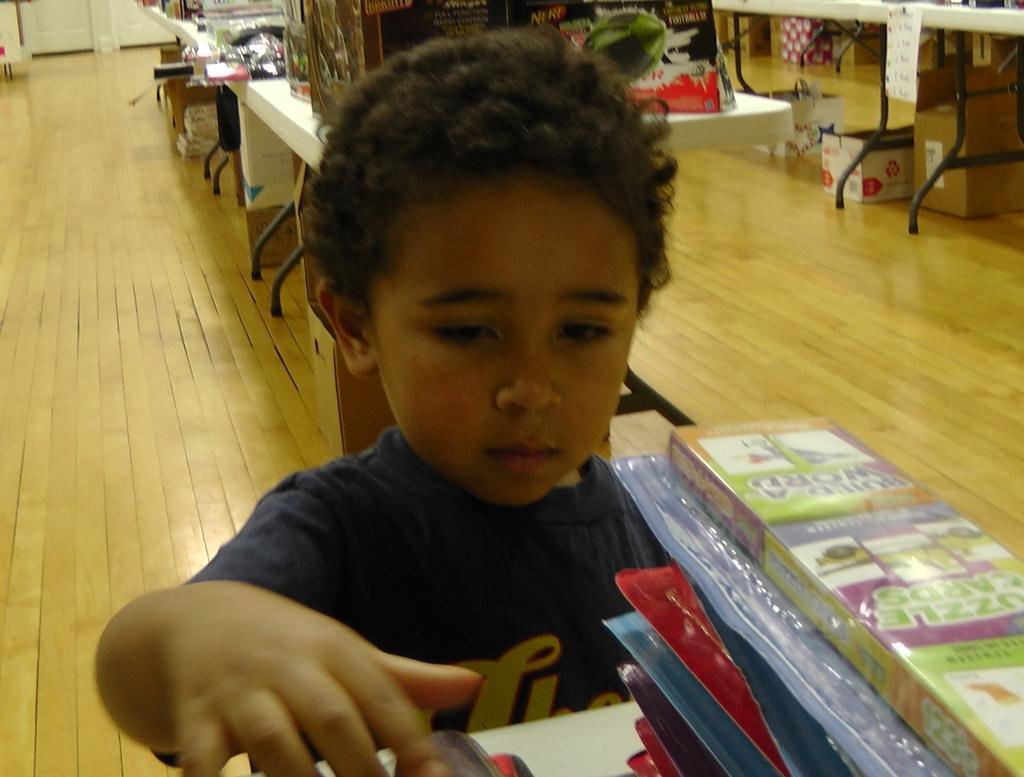Please provide a concise description of this image. In this image, we can see a kid standing, there are some tables, we can see some cartoon boxes on the floor. 